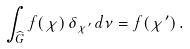<formula> <loc_0><loc_0><loc_500><loc_500>\int _ { \widehat { G } } f ( \chi ) \, \delta _ { \chi ^ { \prime } } \, d \nu = f ( \chi ^ { \prime } ) \, .</formula> 